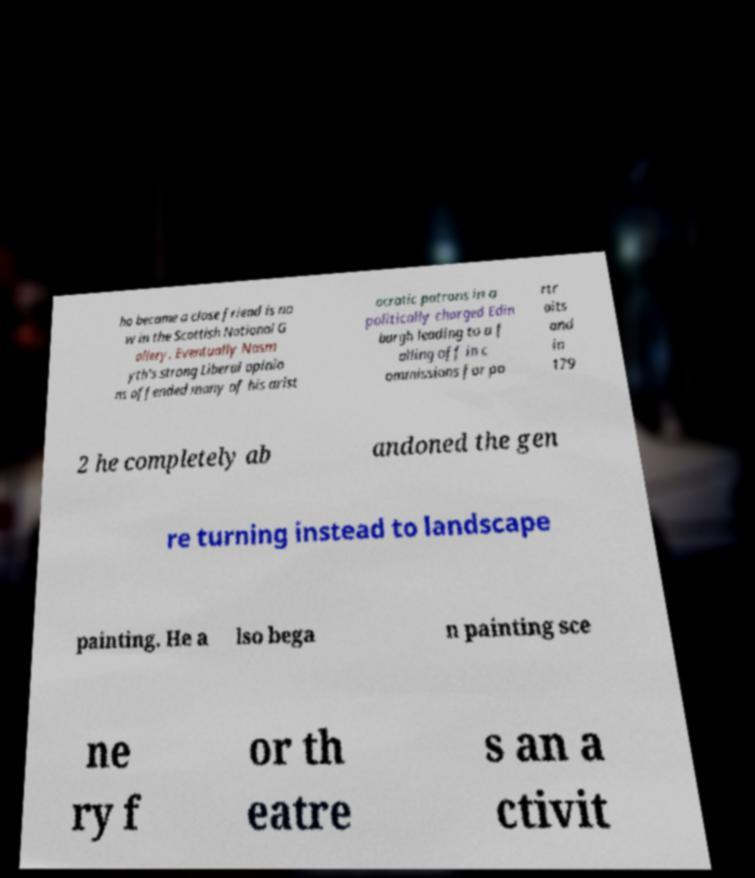What messages or text are displayed in this image? I need them in a readable, typed format. ho became a close friend is no w in the Scottish National G allery. Eventually Nasm yth's strong Liberal opinio ns offended many of his arist ocratic patrons in a politically charged Edin burgh leading to a f alling off in c ommissions for po rtr aits and in 179 2 he completely ab andoned the gen re turning instead to landscape painting. He a lso bega n painting sce ne ry f or th eatre s an a ctivit 